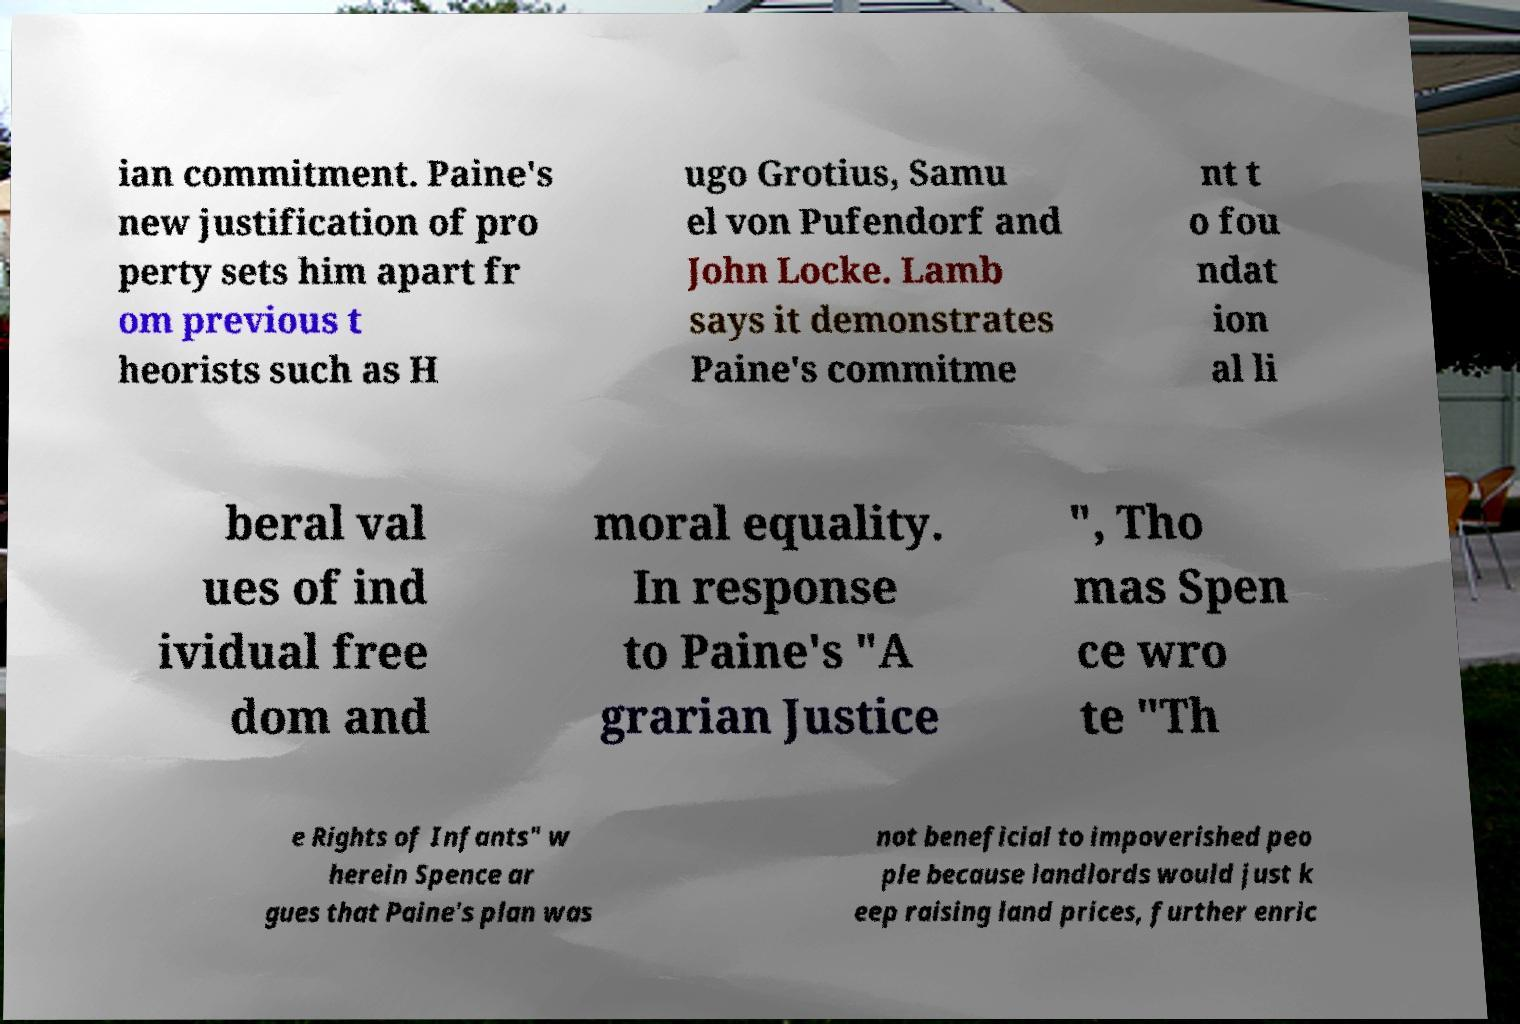Could you assist in decoding the text presented in this image and type it out clearly? ian commitment. Paine's new justification of pro perty sets him apart fr om previous t heorists such as H ugo Grotius, Samu el von Pufendorf and John Locke. Lamb says it demonstrates Paine's commitme nt t o fou ndat ion al li beral val ues of ind ividual free dom and moral equality. In response to Paine's "A grarian Justice ", Tho mas Spen ce wro te "Th e Rights of Infants" w herein Spence ar gues that Paine's plan was not beneficial to impoverished peo ple because landlords would just k eep raising land prices, further enric 